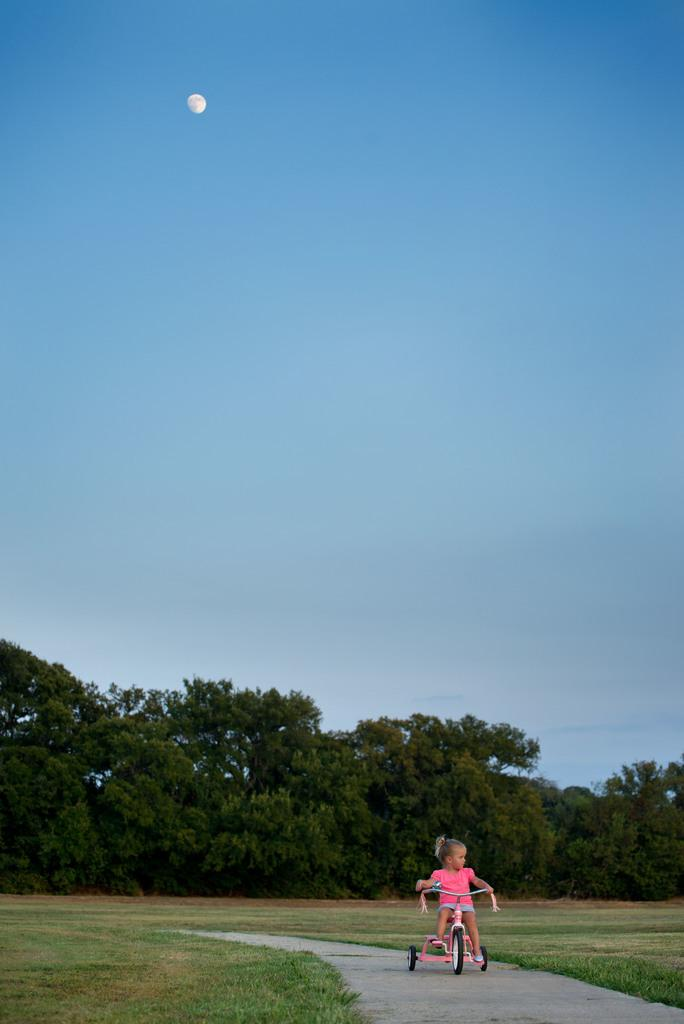Who is the main subject in the image? There is a girl in the image. What is the girl doing in the image? The girl is sitting on a tricycle. What type of vegetation is present at the bottom of the image? There are trees and grass at the bottom of the image. What celestial body can be seen in the sky in the background of the image? The moon is visible in the sky in the background of the image. What type of punishment is the girl receiving for not turning off the light bulb in the image? There is no light bulb or mention of punishment in the image; it only shows a girl sitting on a tricycle with trees, grass, and the moon visible in the background. 